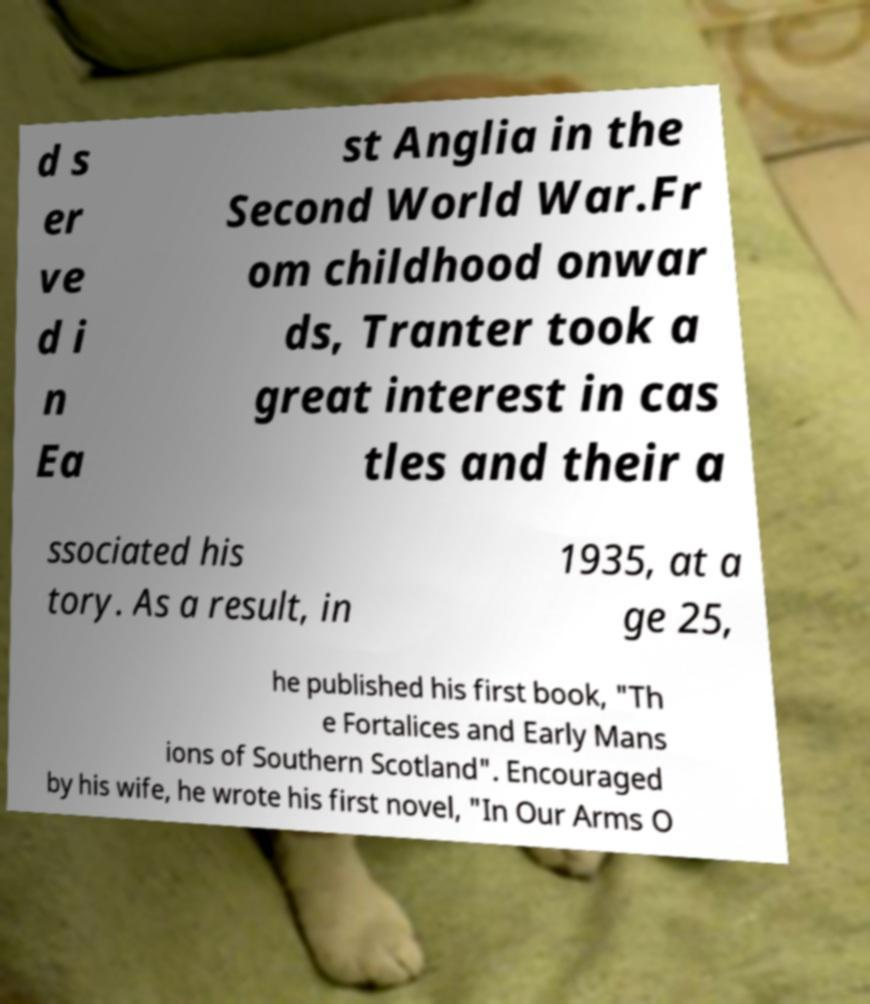Please read and relay the text visible in this image. What does it say? d s er ve d i n Ea st Anglia in the Second World War.Fr om childhood onwar ds, Tranter took a great interest in cas tles and their a ssociated his tory. As a result, in 1935, at a ge 25, he published his first book, "Th e Fortalices and Early Mans ions of Southern Scotland". Encouraged by his wife, he wrote his first novel, "In Our Arms O 